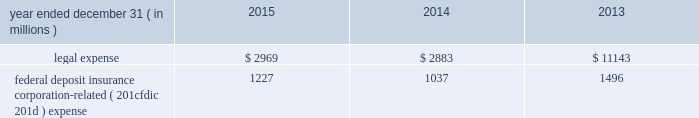Jpmorgan chase & co./2015 annual report 233 note 11 2013 noninterest expense for details on noninterest expense , see consolidated statements of income on page 176 .
Included within other expense is the following : year ended december 31 , ( in millions ) 2015 2014 2013 .
Federal deposit insurance corporation-related ( 201cfdic 201d ) expense 1227 1037 1496 note 12 2013 securities securities are classified as trading , afs or held-to-maturity ( 201chtm 201d ) .
Securities classified as trading assets are discussed in note 3 .
Predominantly all of the firm 2019s afs and htm investment securities ( the 201cinvestment securities portfolio 201d ) are held by treasury and cio in connection with its asset-liability management objectives .
At december 31 , 2015 , the investment securities portfolio consisted of debt securities with an average credit rating of aa+ ( based upon external ratings where available , and where not available , based primarily upon internal ratings which correspond to ratings as defined by s&p and moody 2019s ) .
Afs securities are carried at fair value on the consolidated balance sheets .
Unrealized gains and losses , after any applicable hedge accounting adjustments , are reported as net increases or decreases to accumulated other comprehensive income/ ( loss ) .
The specific identification method is used to determine realized gains and losses on afs securities , which are included in securities gains/ ( losses ) on the consolidated statements of income .
Htm debt securities , which management has the intent and ability to hold until maturity , are carried at amortized cost on the consolidated balance sheets .
For both afs and htm debt securities , purchase discounts or premiums are generally amortized into interest income over the contractual life of the security .
During 2014 , the firm transferred u.s .
Government agency mortgage-backed securities and obligations of u.s .
States and municipalities with a fair value of $ 19.3 billion from afs to htm .
These securities were transferred at fair value , and the transfer was a non-cash transaction .
Aoci included net pretax unrealized losses of $ 9 million on the securities at the date of transfer .
The transfer reflected the firm 2019s intent to hold the securities to maturity in order to reduce the impact of price volatility on aoci and certain capital measures under basel iii. .
What was the minimum legal expense in the past three years? 
Computations: table_min(legal expense, none)
Answer: 2883.0. 